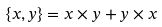Convert formula to latex. <formula><loc_0><loc_0><loc_500><loc_500>\left \{ x , y \right \} = x \times y + y \times x</formula> 